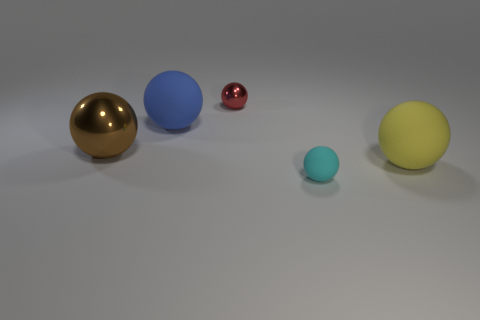How many other objects are there of the same color as the big metal sphere?
Ensure brevity in your answer.  0. How many things are yellow matte objects or large green cylinders?
Your answer should be very brief. 1. What number of objects are either small purple metallic cubes or metallic balls left of the red metallic sphere?
Ensure brevity in your answer.  1. Does the big blue thing have the same material as the small red thing?
Offer a very short reply. No. What number of other things are the same material as the blue ball?
Provide a succinct answer. 2. Is the number of matte things greater than the number of cyan matte things?
Your answer should be very brief. Yes. Do the big rubber object that is left of the cyan object and the yellow thing have the same shape?
Your response must be concise. Yes. Is the number of yellow matte balls less than the number of large cyan metallic balls?
Your response must be concise. No. What is the material of the yellow thing that is the same size as the blue matte thing?
Give a very brief answer. Rubber. Do the tiny shiny sphere and the big ball on the right side of the small cyan ball have the same color?
Your answer should be very brief. No. 